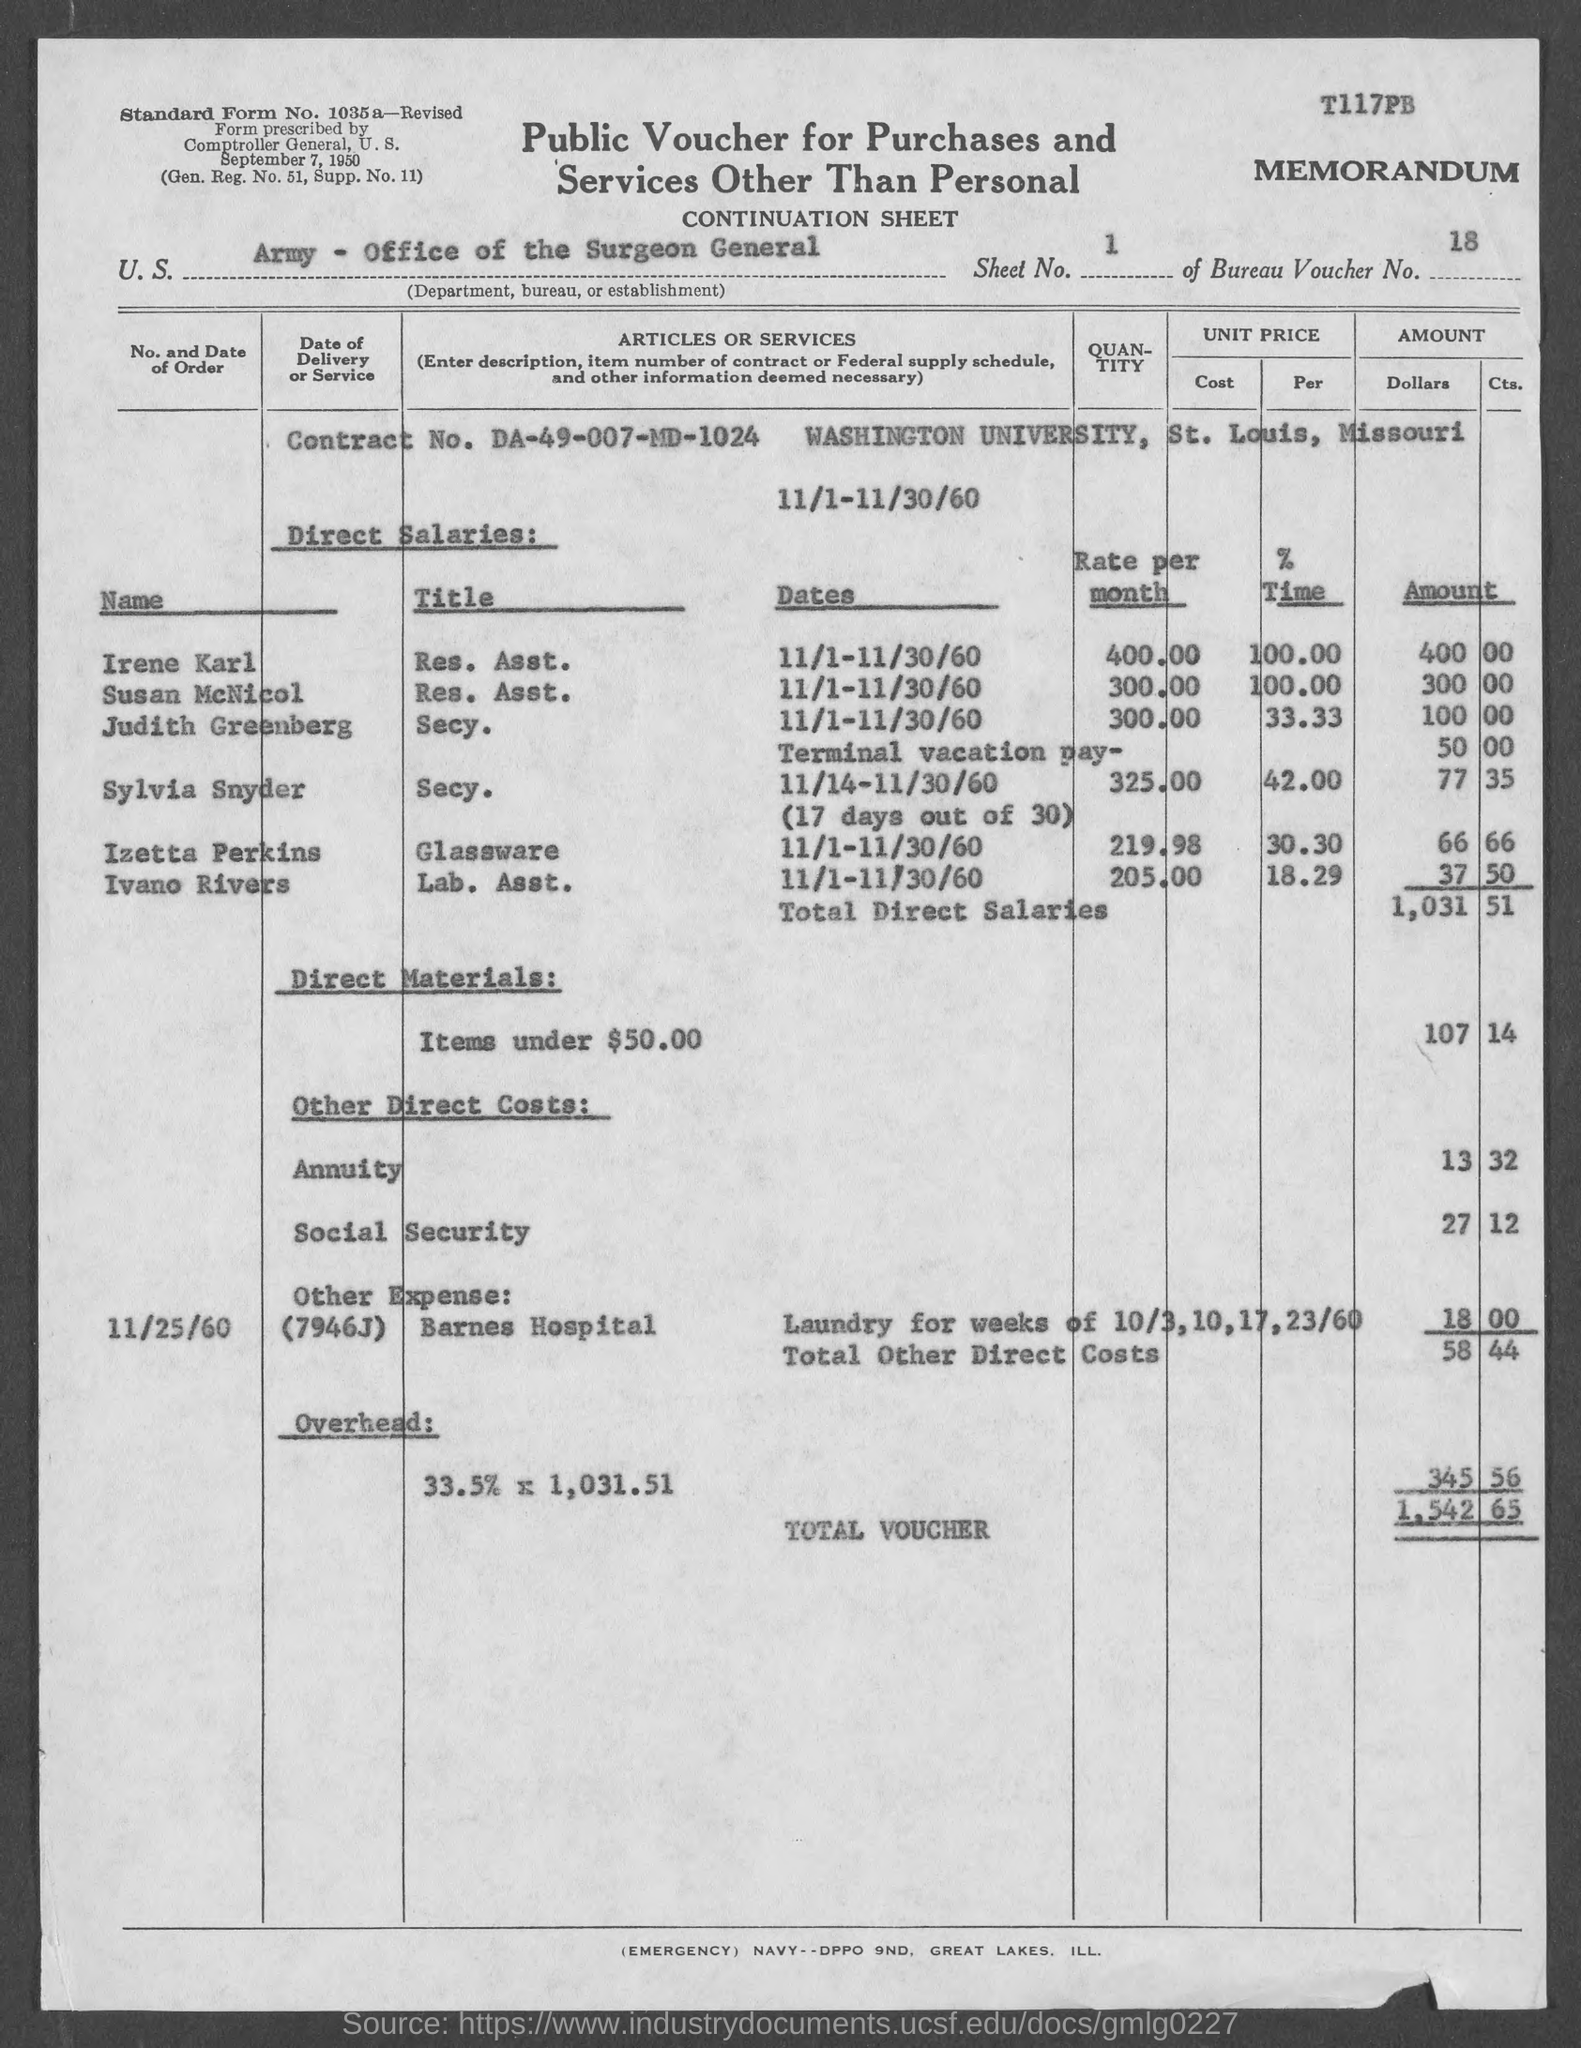Specify some key components in this picture. What is the contract number? DA-49-007-MD-1024..." is a question asking for information about a contract number. Washington University is located in the state of Missouri. The title of Irene Karl's resume as a Resident Assistant is [insert title here]. Susan McNicol is the res. asst. of a title. The total voucher amount is 1,542.65. 